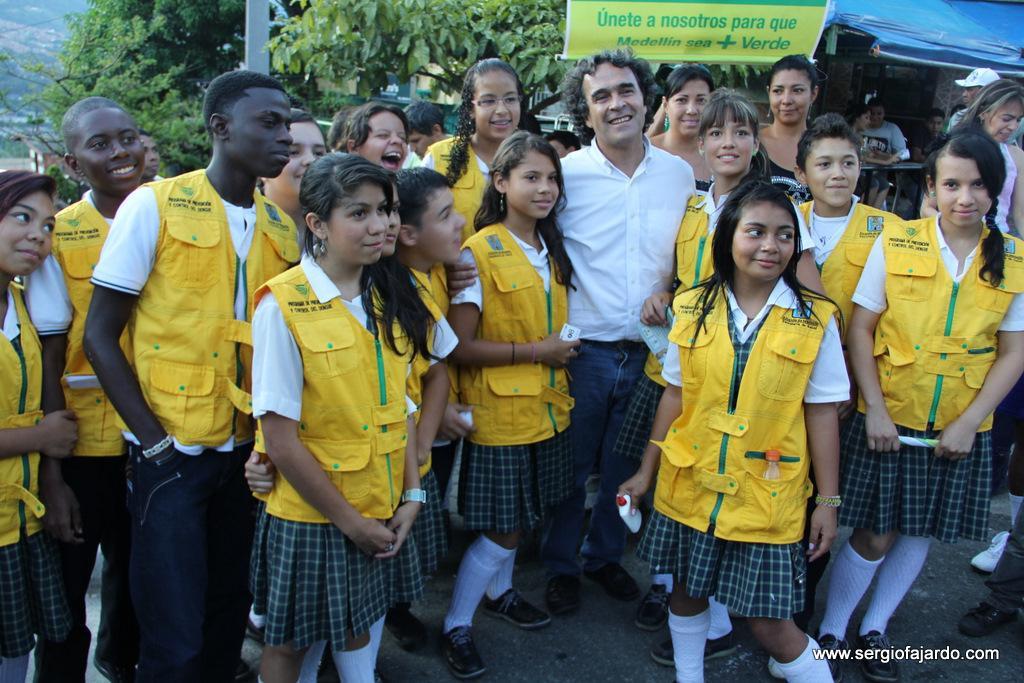How would you summarize this image in a sentence or two? There is a group of persons standing as we can see in the middle of this image. There are some trees and a house in the background. There is a watermark at the bottom right corner of this image. 